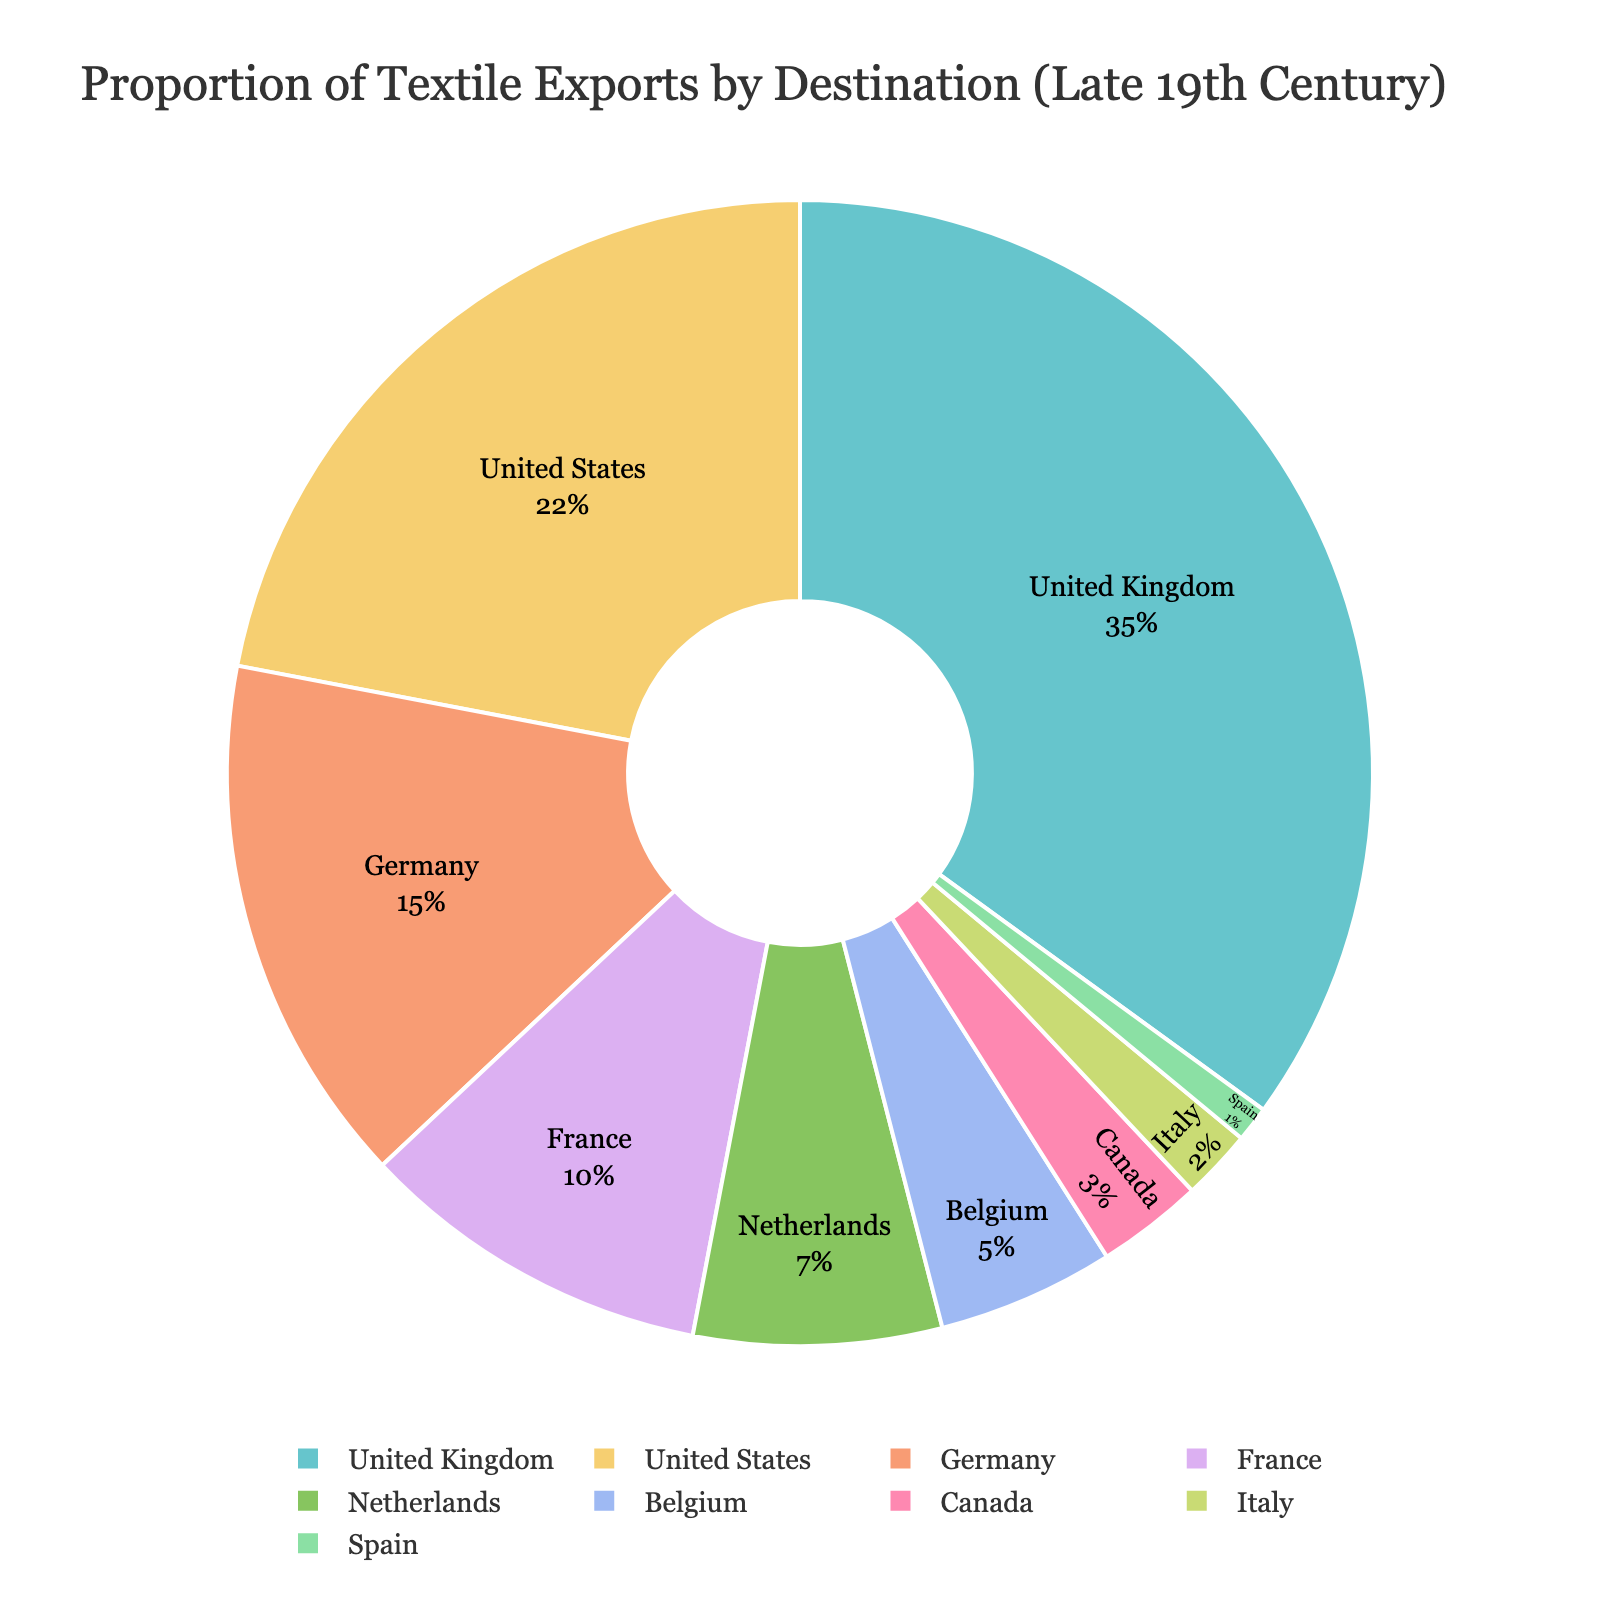What is the proportion of textile exports to the United Kingdom? The slice representing the United Kingdom is labeled with 35%.
Answer: 35% Which country receives a higher proportion of textile exports: Germany or France? Germany has a larger slice labeled with 15%, while France's slice is labeled with 10%, indicating Germany receives a higher proportion.
Answer: Germany What is the combined percentage of textile exports to the Netherlands and Belgium? Add the percentages of the Netherlands (7%) and Belgium (5%) together. 7 + 5 = 12%.
Answer: 12% Which country receives the smallest proportion of textile exports? The slice labeled with the smallest percentage is for Spain, which has 1%.
Answer: Spain Is the proportion of textile exports to the United States greater than the combined proportion to France and the Netherlands? The United States has 22%. France and the Netherlands combined have 10% + 7% = 17%. Therefore, 22% is greater than 17%.
Answer: Yes Which country, apart from the United Kingdom, has a proportion over 20%? The United States is the only other country with its slice labeled 22%.
Answer: United States What is the difference in textile export proportion between the United Kingdom and Germany? Subtract Germany's proportion (15%) from the United Kingdom's proportion (35%). 35 - 15 = 20%.
Answer: 20% How many countries have a textile export proportion of less than 10% each? Countries with less than 10% are the Netherlands, Belgium, Canada, Italy, and Spain, which totals to five countries.
Answer: 5 What is the proportion of textile exports to countries other than the top three (United Kingdom, United States, Germany)? Sum the proportions of France (10%), Netherlands (7%), Belgium (5%), Canada (3%), Italy (2%), and Spain (1%). 10+7+5+3+2+1 = 28%.
Answer: 28% 